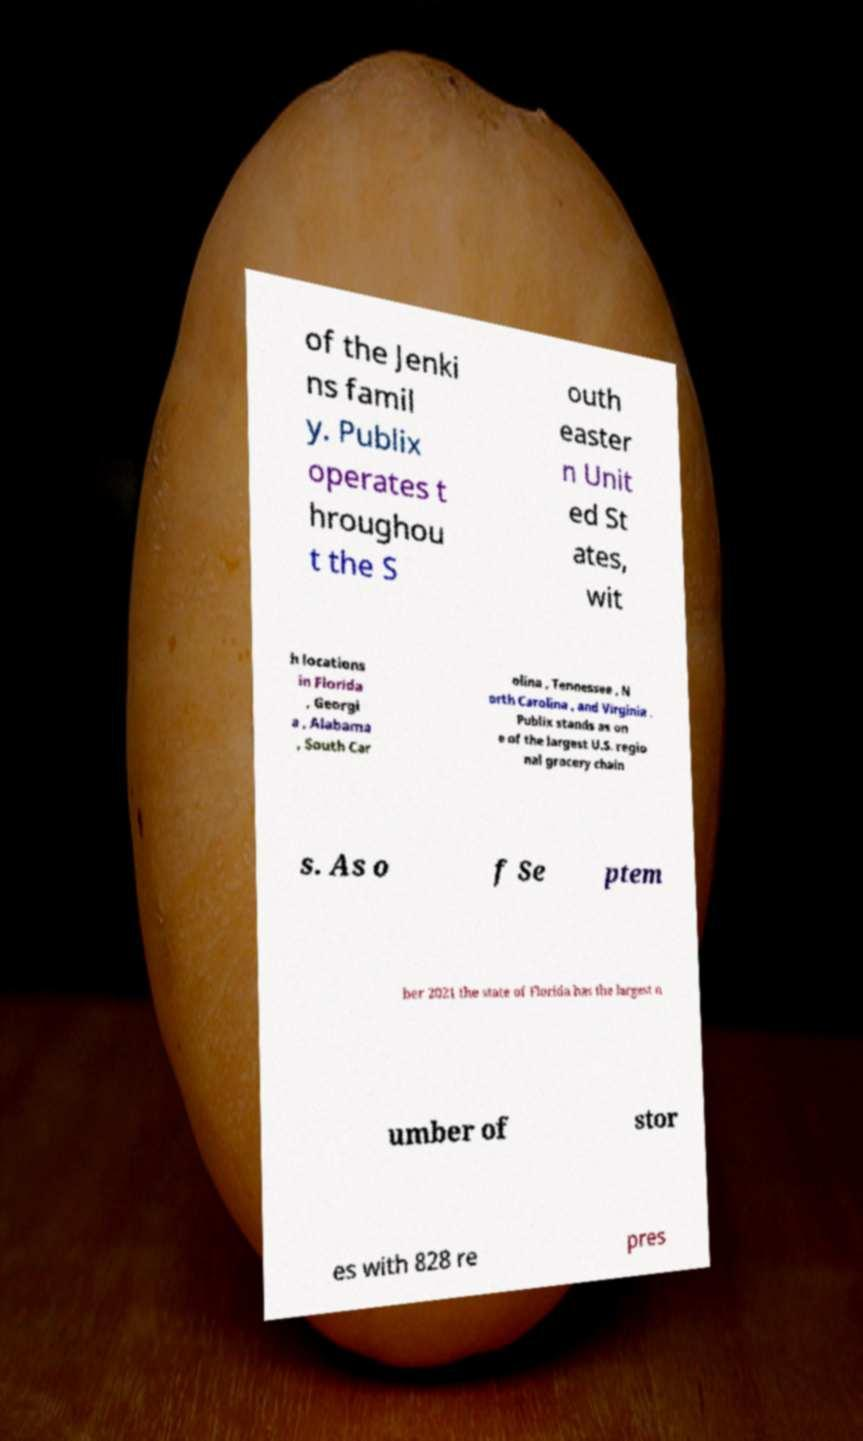What messages or text are displayed in this image? I need them in a readable, typed format. of the Jenki ns famil y. Publix operates t hroughou t the S outh easter n Unit ed St ates, wit h locations in Florida , Georgi a , Alabama , South Car olina , Tennessee , N orth Carolina , and Virginia . Publix stands as on e of the largest U.S. regio nal grocery chain s. As o f Se ptem ber 2021 the state of Florida has the largest n umber of stor es with 828 re pres 